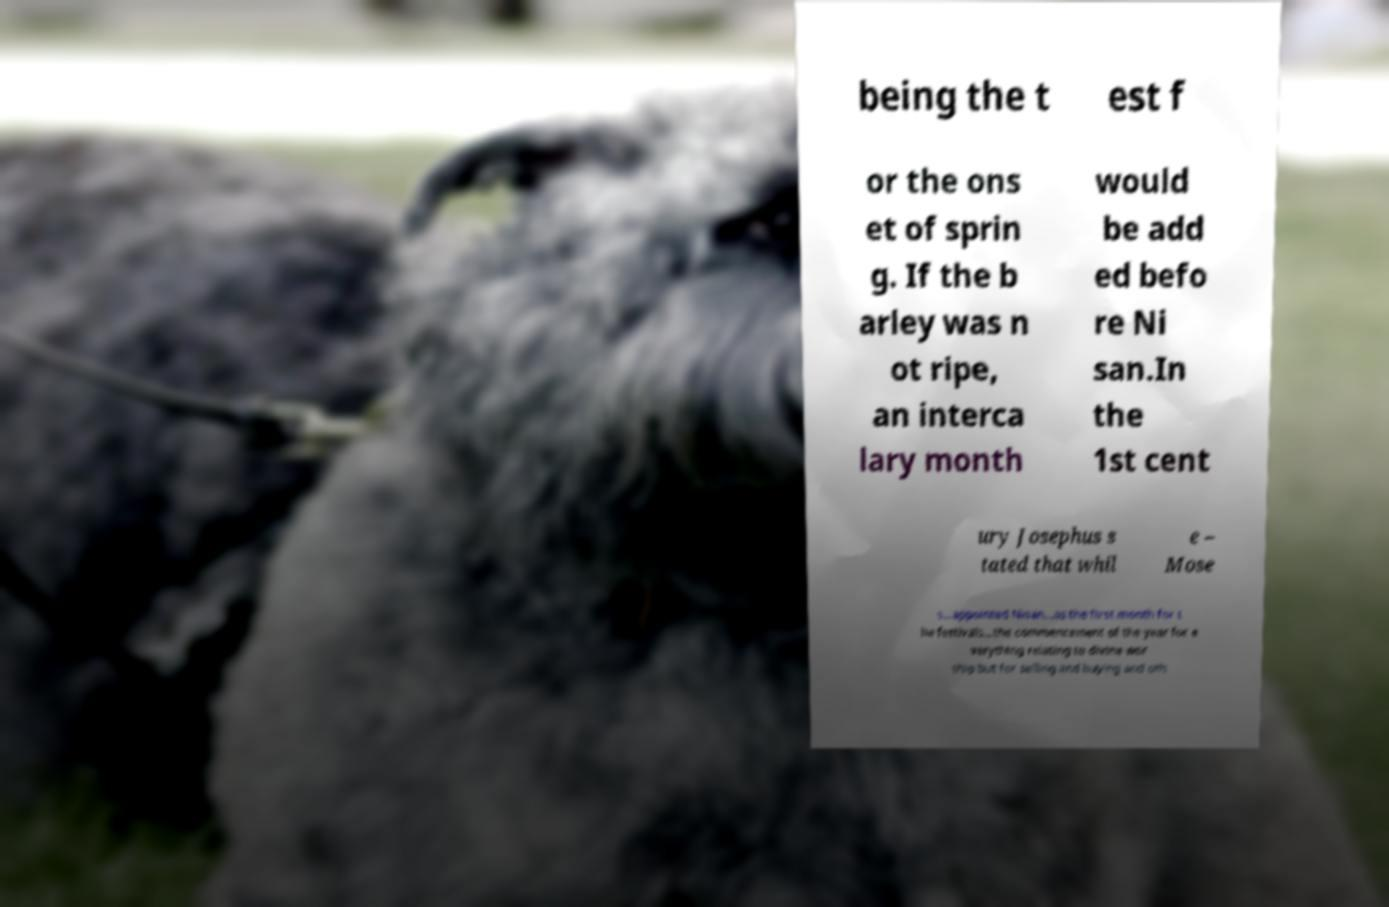Could you assist in decoding the text presented in this image and type it out clearly? being the t est f or the ons et of sprin g. If the b arley was n ot ripe, an interca lary month would be add ed befo re Ni san.In the 1st cent ury Josephus s tated that whil e – Mose s...appointed Nisan...as the first month for t he festivals...the commencement of the year for e verything relating to divine wor ship but for selling and buying and oth 